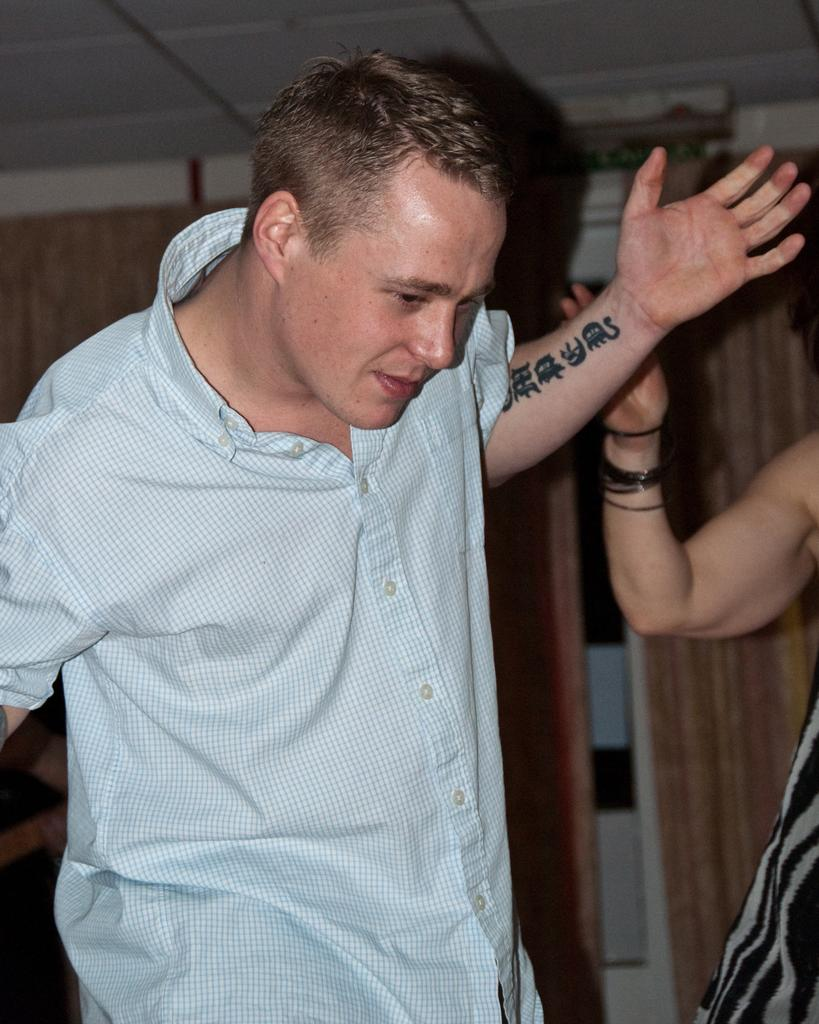Who is present in the image? There is a man and another person in the image. What is the man wearing? The man is wearing a shirt. Can you describe any unique features of the man? The man has a tattoo on his hands. What can be seen in the background of the image? There are curtains in the background of the image. What type of amusement can be seen on the roof in the image? There is no roof or amusement present in the image. Can you provide a fact about the tattoo on the man's hands? The provided facts do not include any information about the meaning or origin of the tattoo on the man's hands. 